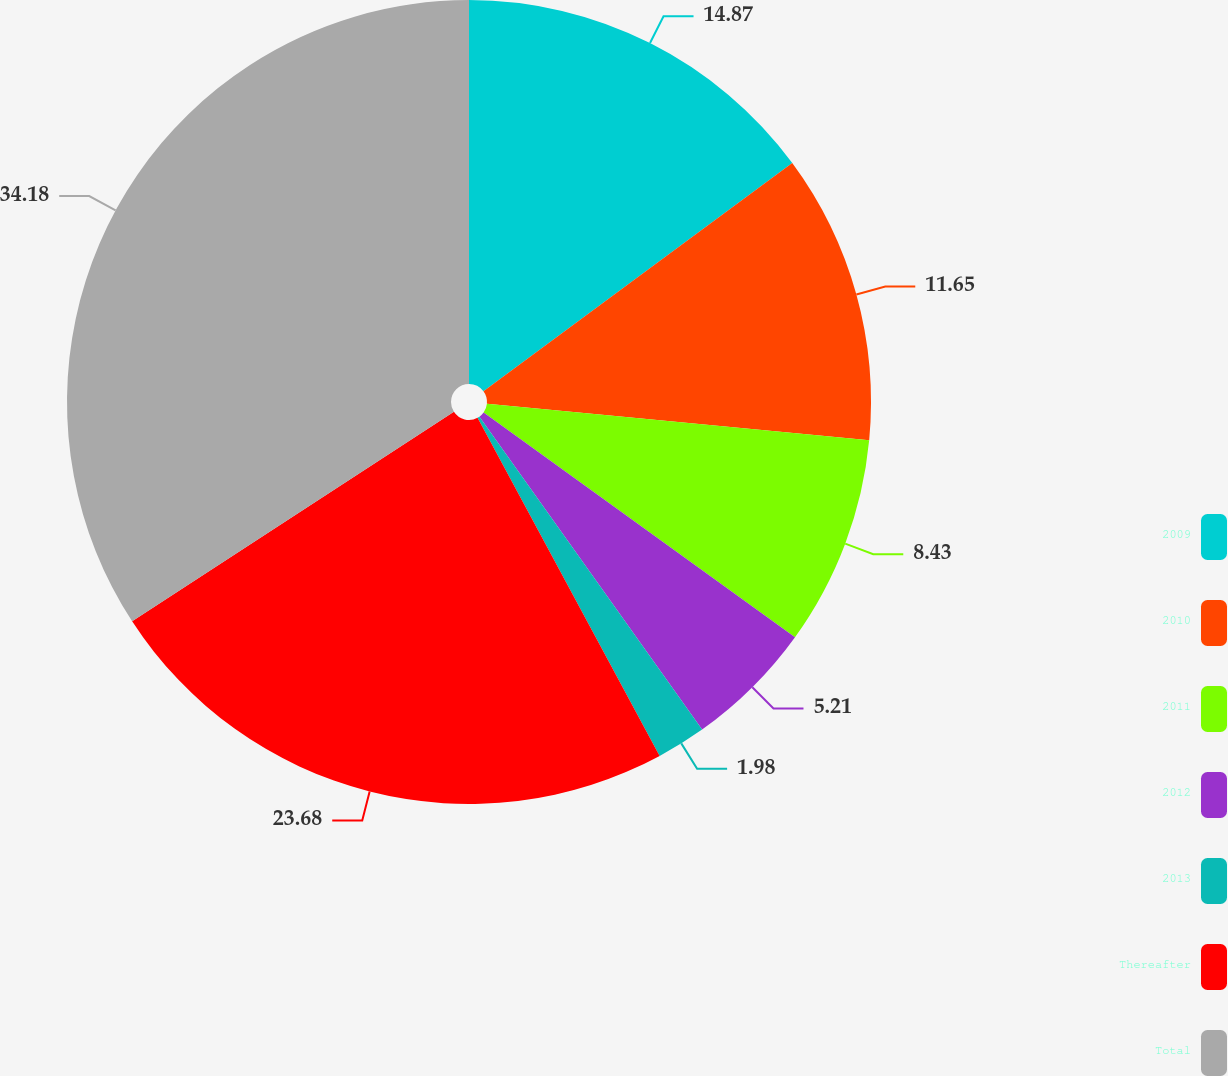Convert chart to OTSL. <chart><loc_0><loc_0><loc_500><loc_500><pie_chart><fcel>2009<fcel>2010<fcel>2011<fcel>2012<fcel>2013<fcel>Thereafter<fcel>Total<nl><fcel>14.87%<fcel>11.65%<fcel>8.43%<fcel>5.21%<fcel>1.98%<fcel>23.68%<fcel>34.19%<nl></chart> 